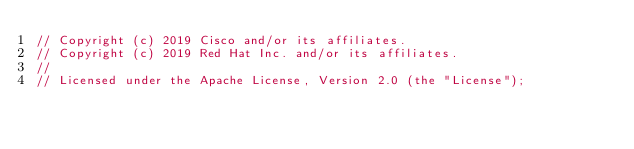Convert code to text. <code><loc_0><loc_0><loc_500><loc_500><_Go_>// Copyright (c) 2019 Cisco and/or its affiliates.
// Copyright (c) 2019 Red Hat Inc. and/or its affiliates.
//
// Licensed under the Apache License, Version 2.0 (the "License");</code> 